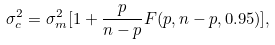<formula> <loc_0><loc_0><loc_500><loc_500>\sigma ^ { 2 } _ { c } = \sigma ^ { 2 } _ { m } [ 1 + \frac { p } { n - p } F ( p , n - p , 0 . 9 5 ) ] ,</formula> 